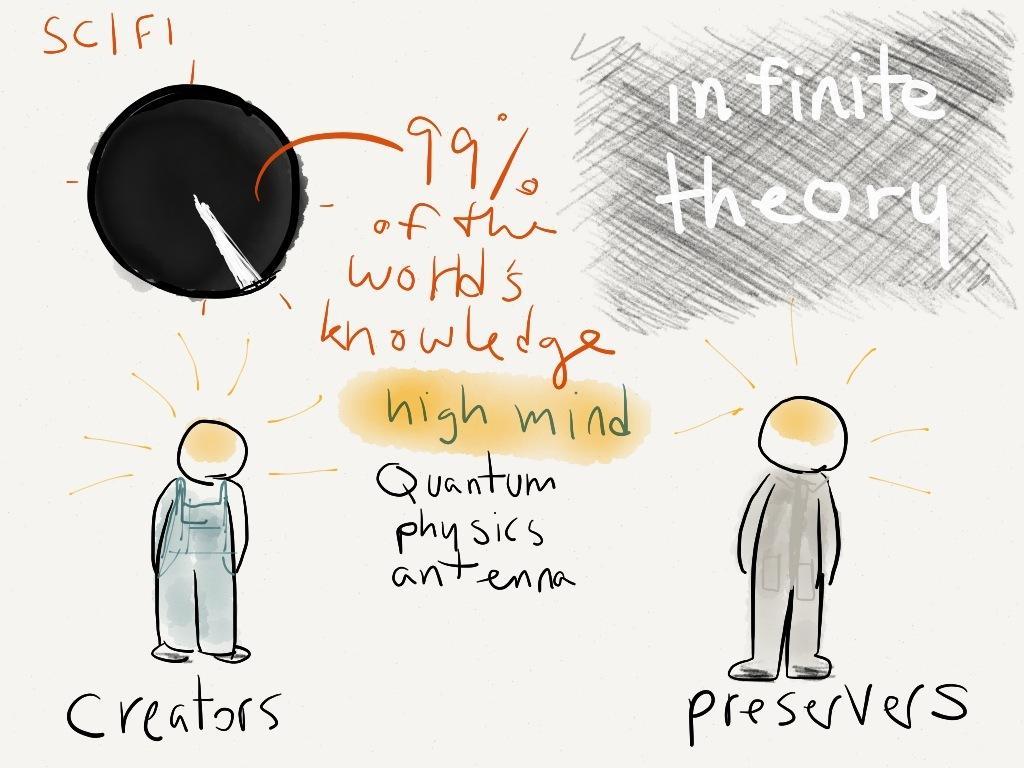Could you give a brief overview of what you see in this image? This picture is a poster contains two cartoons and text written on it 